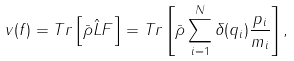Convert formula to latex. <formula><loc_0><loc_0><loc_500><loc_500>v ( f ) = T r \left [ \bar { \rho } \hat { L } F \right ] = T r \left [ \bar { \rho } \sum _ { i = 1 } ^ { N } \delta ( q _ { i } ) \frac { p _ { i } } { m _ { i } } \right ] ,</formula> 